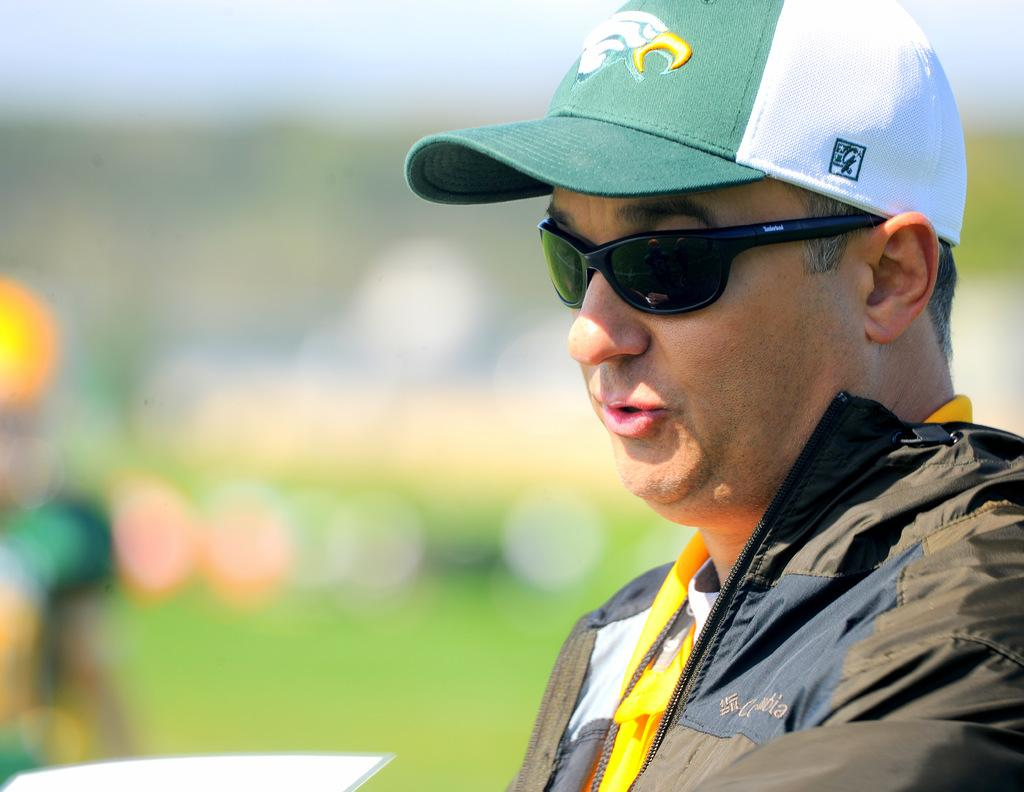Who or what is the main subject in the image? There is a person in the image. Can you describe the person's appearance? The person is wearing spectacles and a green color cap. What is the person's tendency towards harboring balance in the image? There is no information about the person's tendencies or balance in the image. 